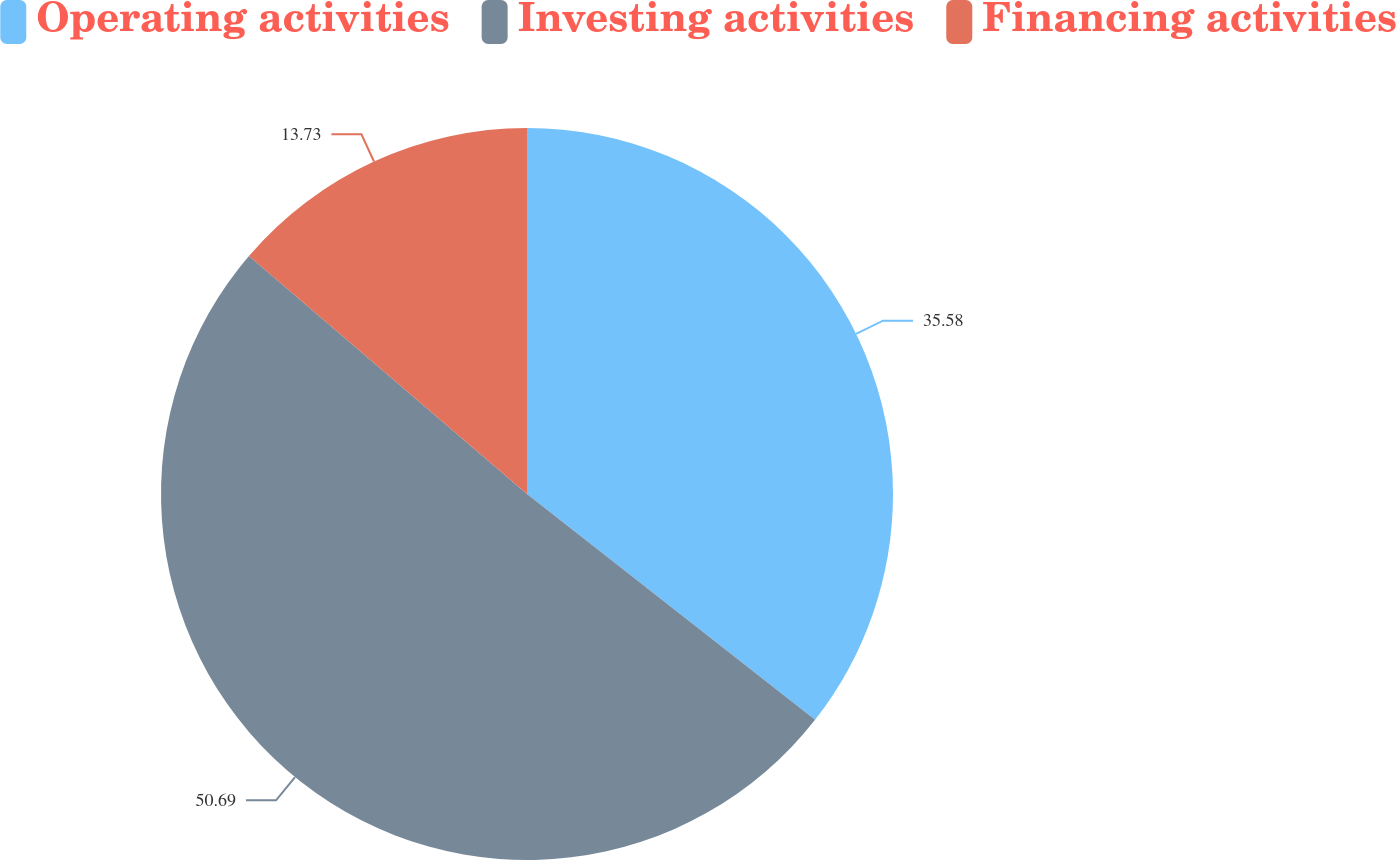Convert chart to OTSL. <chart><loc_0><loc_0><loc_500><loc_500><pie_chart><fcel>Operating activities<fcel>Investing activities<fcel>Financing activities<nl><fcel>35.58%<fcel>50.69%<fcel>13.73%<nl></chart> 